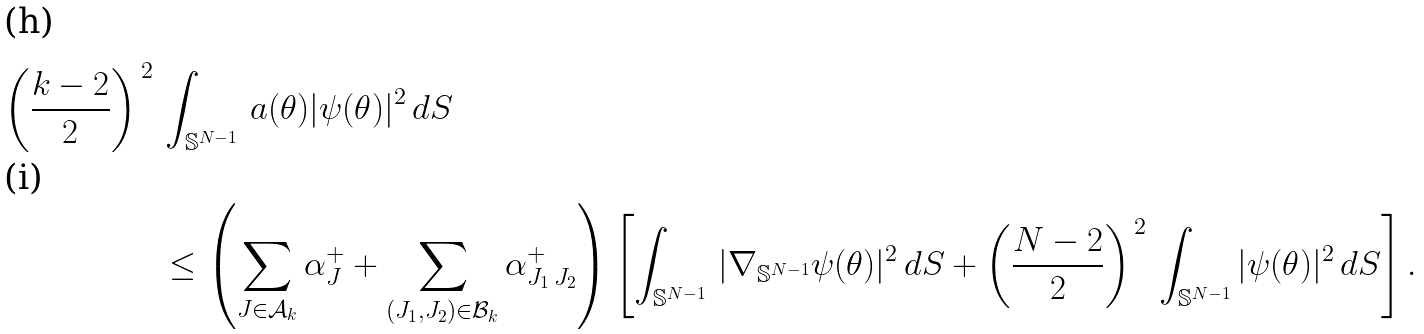<formula> <loc_0><loc_0><loc_500><loc_500>\left ( \frac { k - 2 } 2 \right ) ^ { \, 2 } \, & \int _ { { \mathbb { S } } ^ { N - 1 } } \, a ( \theta ) | \psi ( \theta ) | ^ { 2 } \, d S \\ & \leq \left ( \sum _ { J \in { \mathcal { A } } _ { k } } \alpha _ { J } ^ { + } + \sum _ { ( J _ { 1 } , J _ { 2 } ) \in \mathcal { B } _ { k } } \alpha _ { J _ { 1 } \, J _ { 2 } } ^ { + } \right ) \left [ \int _ { { \mathbb { S } } ^ { N - 1 } } \, | \nabla _ { { \mathbb { S } } ^ { N - 1 } } \psi ( \theta ) | ^ { 2 } \, d S + \left ( \frac { N - 2 } 2 \right ) ^ { \, 2 } \, \int _ { { \mathbb { S } } ^ { N - 1 } } | \psi ( \theta ) | ^ { 2 } \, d S \right ] .</formula> 